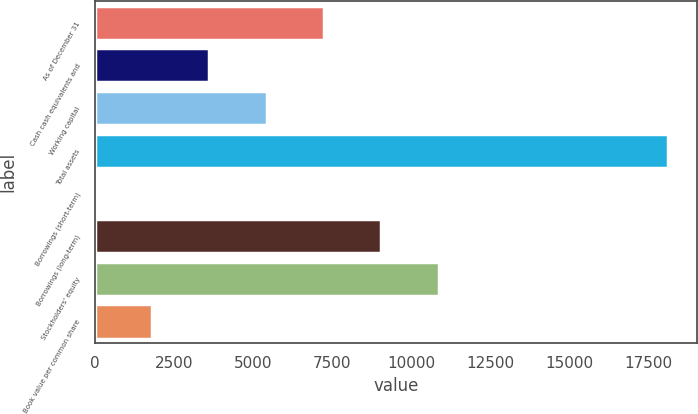<chart> <loc_0><loc_0><loc_500><loc_500><bar_chart><fcel>As of December 31<fcel>Cash cash equivalents and<fcel>Working capital<fcel>Total assets<fcel>Borrowings (short-term)<fcel>Borrowings (long-term)<fcel>Stockholders' equity<fcel>Book value per common share<nl><fcel>7255<fcel>3629<fcel>5442<fcel>18133<fcel>3<fcel>9068<fcel>10881<fcel>1816<nl></chart> 